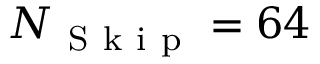<formula> <loc_0><loc_0><loc_500><loc_500>N _ { S k i p } = 6 4</formula> 